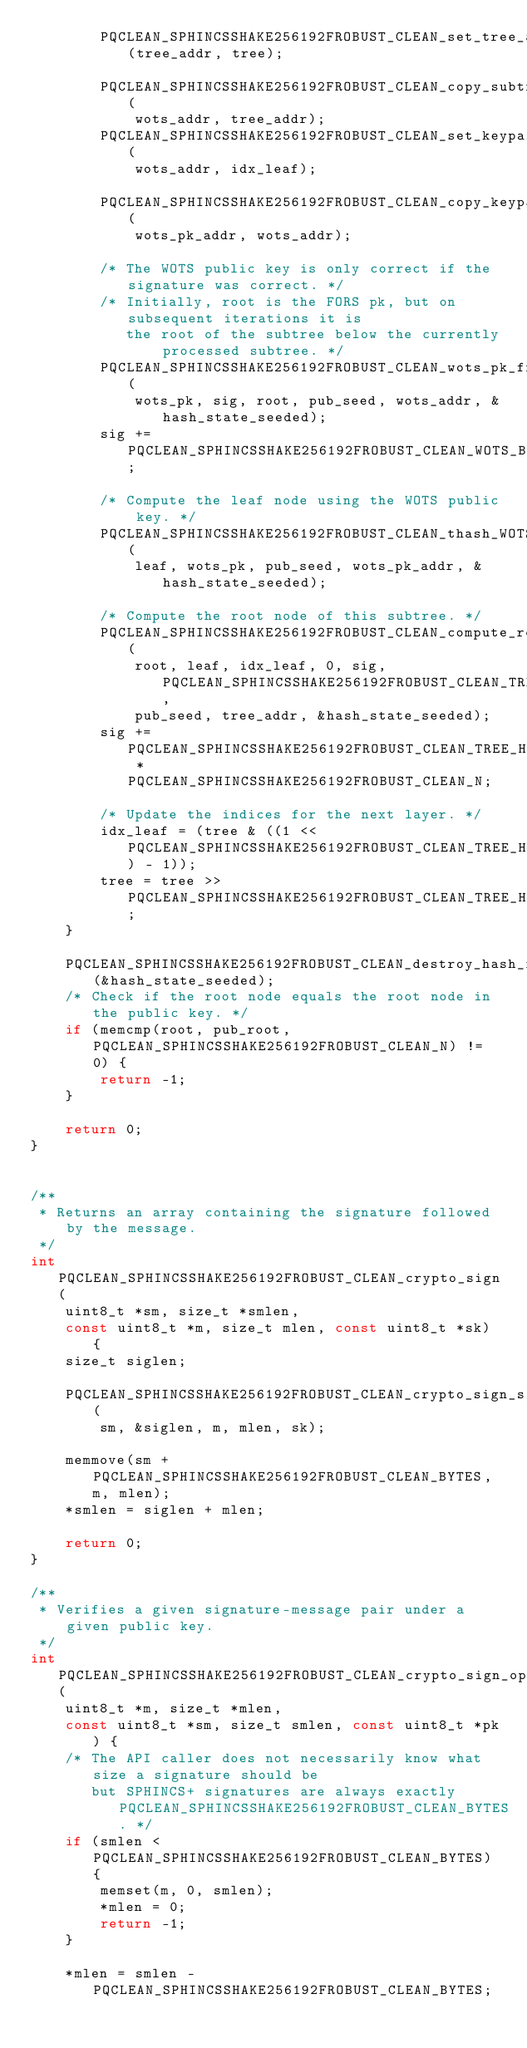Convert code to text. <code><loc_0><loc_0><loc_500><loc_500><_C_>        PQCLEAN_SPHINCSSHAKE256192FROBUST_CLEAN_set_tree_addr(tree_addr, tree);

        PQCLEAN_SPHINCSSHAKE256192FROBUST_CLEAN_copy_subtree_addr(
            wots_addr, tree_addr);
        PQCLEAN_SPHINCSSHAKE256192FROBUST_CLEAN_set_keypair_addr(
            wots_addr, idx_leaf);

        PQCLEAN_SPHINCSSHAKE256192FROBUST_CLEAN_copy_keypair_addr(
            wots_pk_addr, wots_addr);

        /* The WOTS public key is only correct if the signature was correct. */
        /* Initially, root is the FORS pk, but on subsequent iterations it is
           the root of the subtree below the currently processed subtree. */
        PQCLEAN_SPHINCSSHAKE256192FROBUST_CLEAN_wots_pk_from_sig(
            wots_pk, sig, root, pub_seed, wots_addr, &hash_state_seeded);
        sig += PQCLEAN_SPHINCSSHAKE256192FROBUST_CLEAN_WOTS_BYTES;

        /* Compute the leaf node using the WOTS public key. */
        PQCLEAN_SPHINCSSHAKE256192FROBUST_CLEAN_thash_WOTS_LEN(
            leaf, wots_pk, pub_seed, wots_pk_addr, &hash_state_seeded);

        /* Compute the root node of this subtree. */
        PQCLEAN_SPHINCSSHAKE256192FROBUST_CLEAN_compute_root(
            root, leaf, idx_leaf, 0, sig, PQCLEAN_SPHINCSSHAKE256192FROBUST_CLEAN_TREE_HEIGHT,
            pub_seed, tree_addr, &hash_state_seeded);
        sig += PQCLEAN_SPHINCSSHAKE256192FROBUST_CLEAN_TREE_HEIGHT * PQCLEAN_SPHINCSSHAKE256192FROBUST_CLEAN_N;

        /* Update the indices for the next layer. */
        idx_leaf = (tree & ((1 << PQCLEAN_SPHINCSSHAKE256192FROBUST_CLEAN_TREE_HEIGHT) - 1));
        tree = tree >> PQCLEAN_SPHINCSSHAKE256192FROBUST_CLEAN_TREE_HEIGHT;
    }

    PQCLEAN_SPHINCSSHAKE256192FROBUST_CLEAN_destroy_hash_function(&hash_state_seeded);
    /* Check if the root node equals the root node in the public key. */
    if (memcmp(root, pub_root, PQCLEAN_SPHINCSSHAKE256192FROBUST_CLEAN_N) != 0) {
        return -1;
    }

    return 0;
}


/**
 * Returns an array containing the signature followed by the message.
 */
int PQCLEAN_SPHINCSSHAKE256192FROBUST_CLEAN_crypto_sign(
    uint8_t *sm, size_t *smlen,
    const uint8_t *m, size_t mlen, const uint8_t *sk) {
    size_t siglen;

    PQCLEAN_SPHINCSSHAKE256192FROBUST_CLEAN_crypto_sign_signature(
        sm, &siglen, m, mlen, sk);

    memmove(sm + PQCLEAN_SPHINCSSHAKE256192FROBUST_CLEAN_BYTES, m, mlen);
    *smlen = siglen + mlen;

    return 0;
}

/**
 * Verifies a given signature-message pair under a given public key.
 */
int PQCLEAN_SPHINCSSHAKE256192FROBUST_CLEAN_crypto_sign_open(
    uint8_t *m, size_t *mlen,
    const uint8_t *sm, size_t smlen, const uint8_t *pk) {
    /* The API caller does not necessarily know what size a signature should be
       but SPHINCS+ signatures are always exactly PQCLEAN_SPHINCSSHAKE256192FROBUST_CLEAN_BYTES. */
    if (smlen < PQCLEAN_SPHINCSSHAKE256192FROBUST_CLEAN_BYTES) {
        memset(m, 0, smlen);
        *mlen = 0;
        return -1;
    }

    *mlen = smlen - PQCLEAN_SPHINCSSHAKE256192FROBUST_CLEAN_BYTES;
</code> 